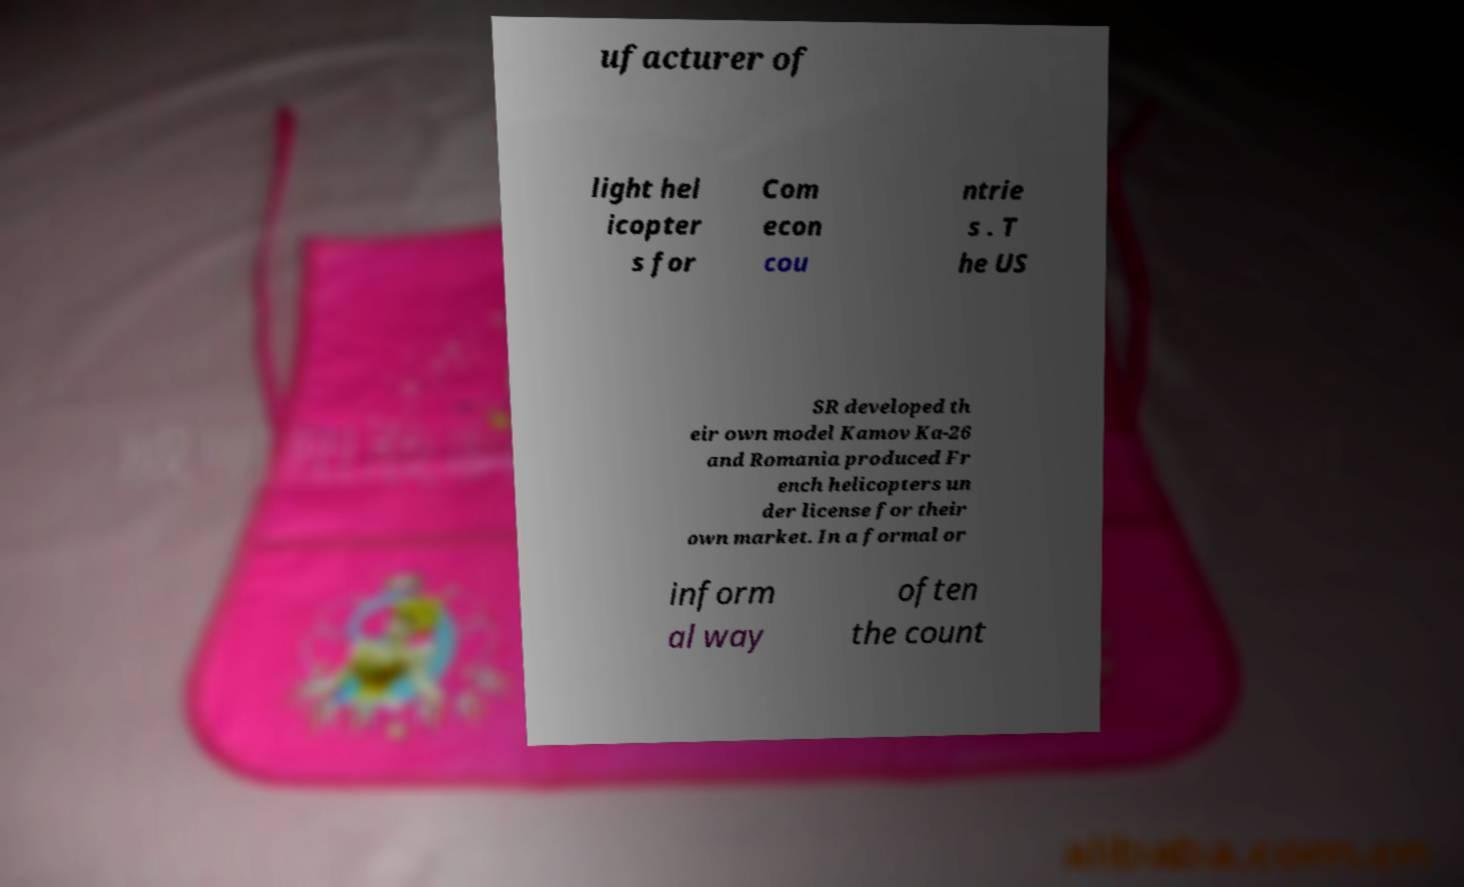Please identify and transcribe the text found in this image. ufacturer of light hel icopter s for Com econ cou ntrie s . T he US SR developed th eir own model Kamov Ka-26 and Romania produced Fr ench helicopters un der license for their own market. In a formal or inform al way often the count 